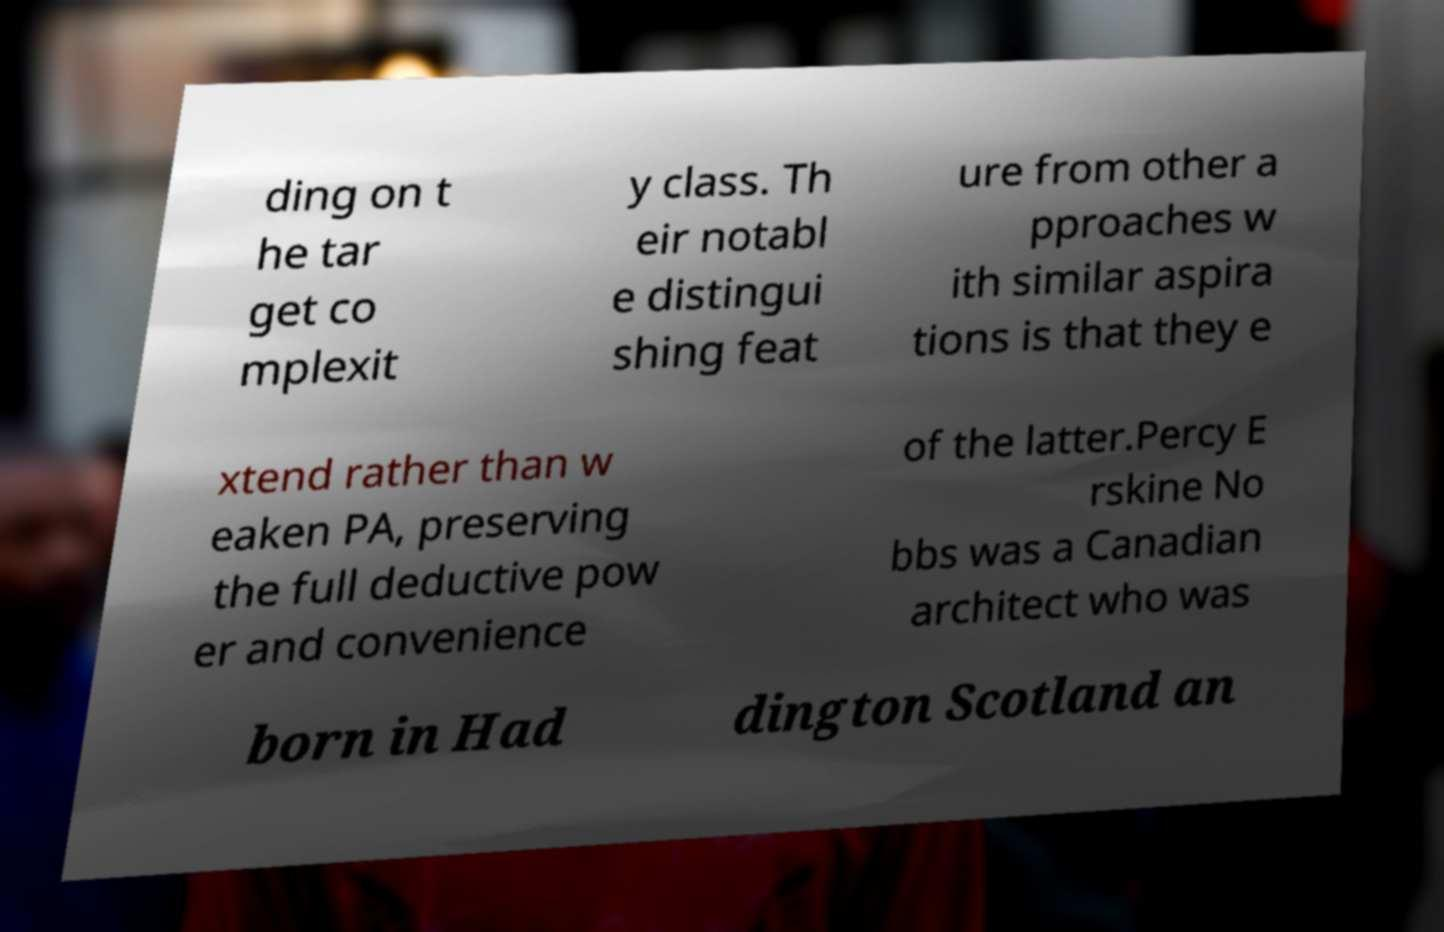There's text embedded in this image that I need extracted. Can you transcribe it verbatim? ding on t he tar get co mplexit y class. Th eir notabl e distingui shing feat ure from other a pproaches w ith similar aspira tions is that they e xtend rather than w eaken PA, preserving the full deductive pow er and convenience of the latter.Percy E rskine No bbs was a Canadian architect who was born in Had dington Scotland an 